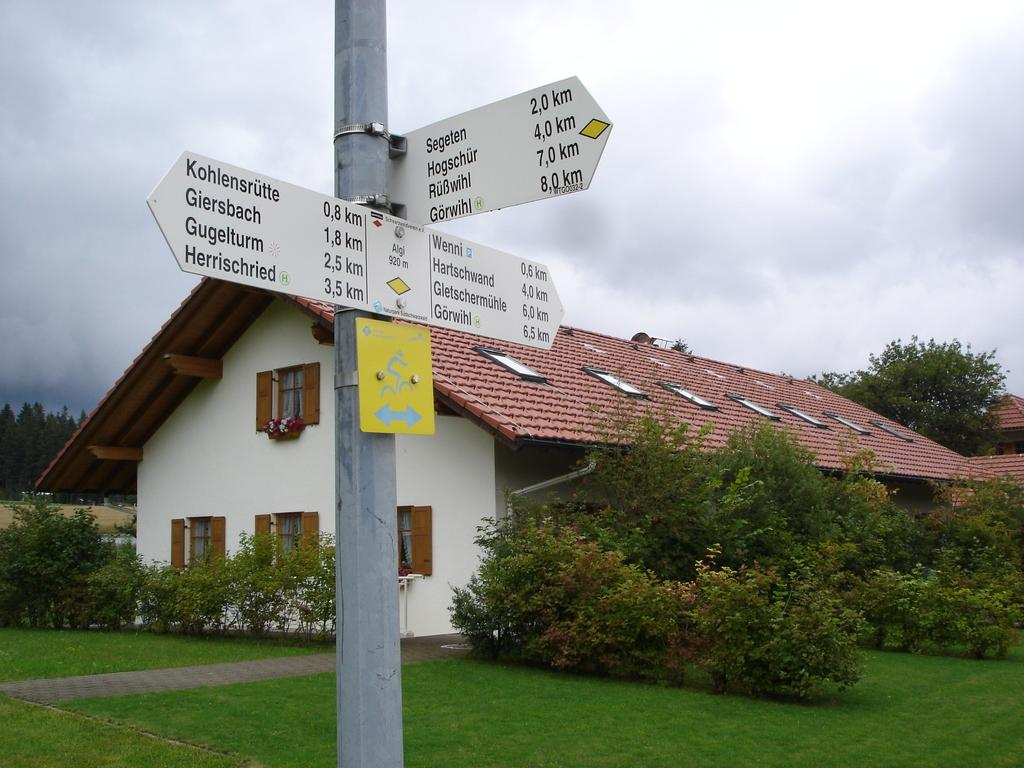Provide a one-sentence caption for the provided image. A sign post  which indicates it is 2.0 km to Segeten. 